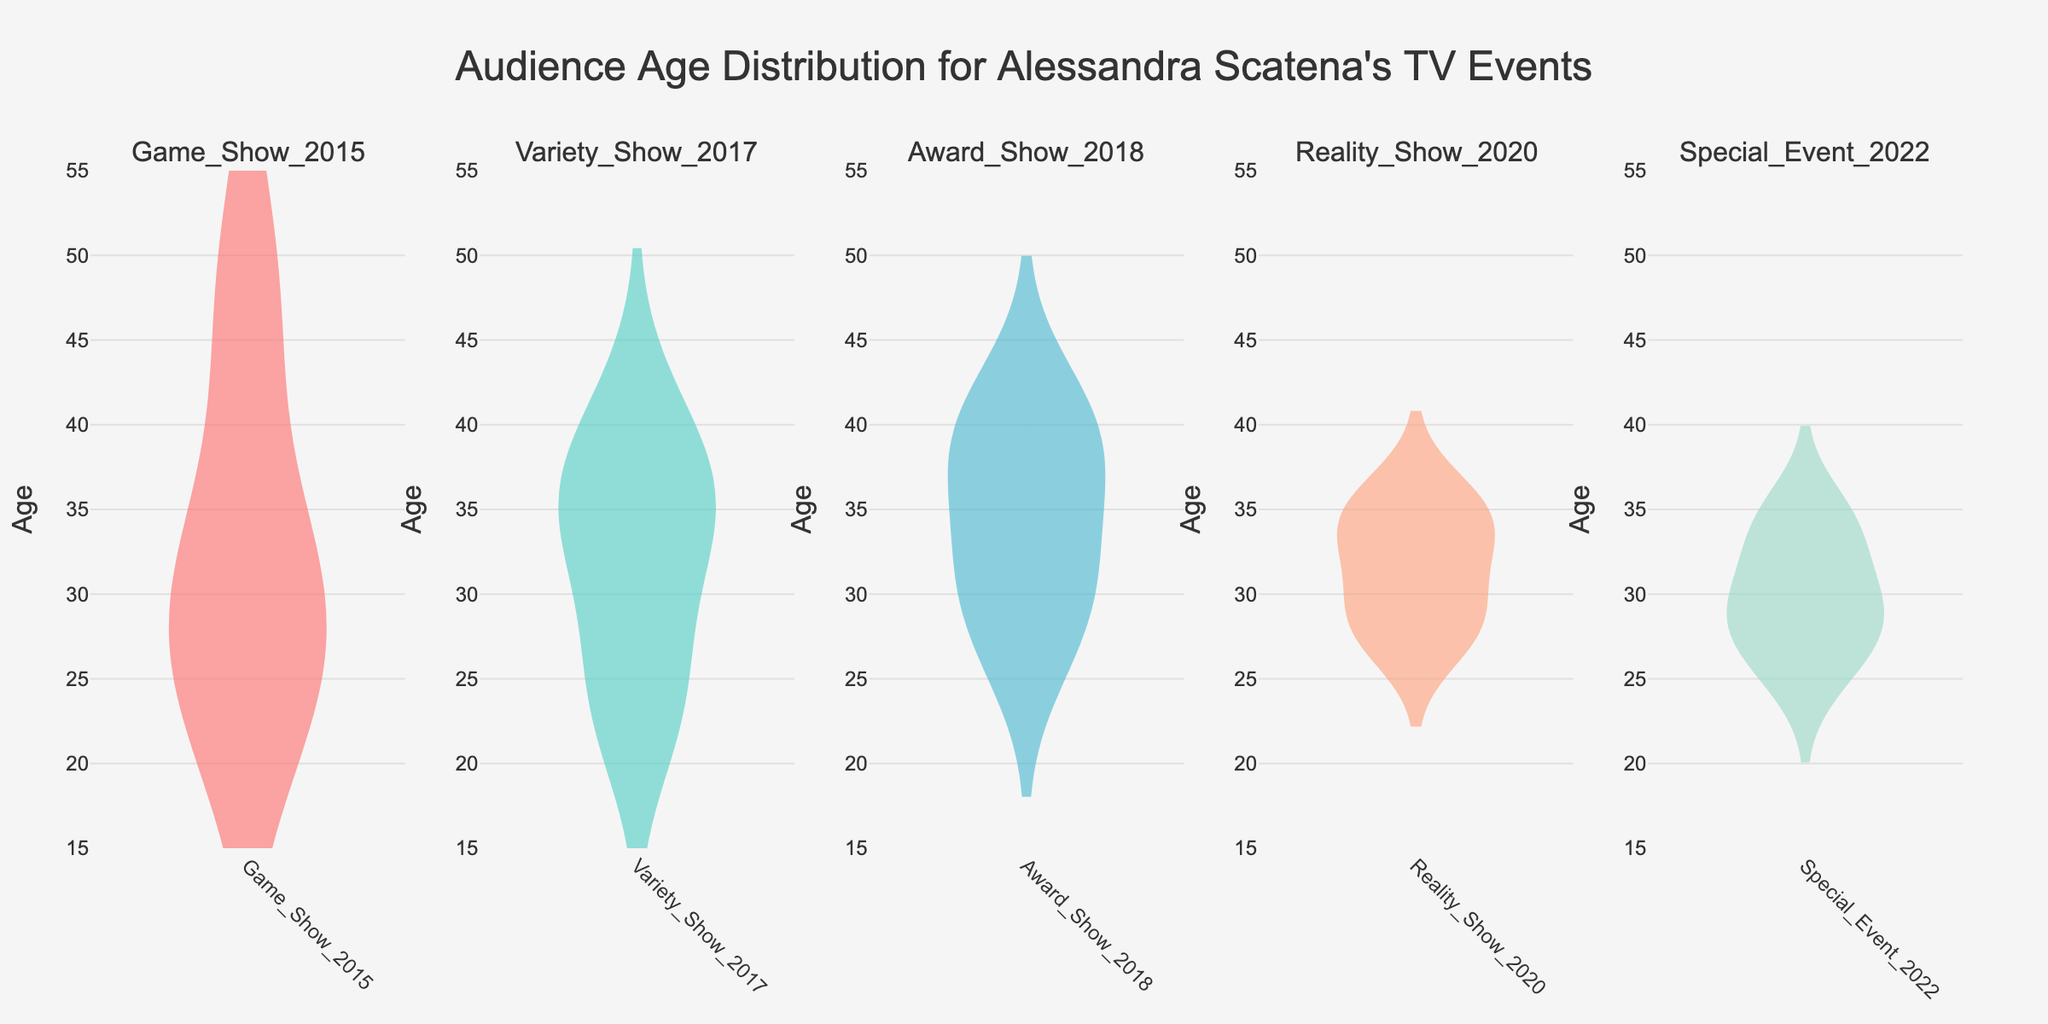What is the title of the figure? The title is found at the top of the figure. It provides an overview of what the figure represents.
Answer: Audience Age Distribution for Alessandra Scatena's TV Events How many subplots are there in the figure? The figure is divided into multiple vertical sections, each representing a different televised event. Count the number of these sections to determine the number of subplots.
Answer: 5 What is the age range covered on the y-axis? Look at the numerical values on the y-axis to determine the minimum and maximum values represented.
Answer: 15 to 55 Which event shows the widest age distribution? Compare the spread of the data points (indicated by the width of the violin plots) across the different events to determine which one is the widest.
Answer: Game_Show_2015 Which event has the highest median age? Locate the central mark on each violin plot that denotes the median age and determine which subplot has the highest median.
Answer: Award_Show_2018 How does the median age of the 'Reality_Show_2020' compare to the 'Special_Event_2022'? Identify the median indicators on the violin plots for these two events and compare their values to see which one is higher.
Answer: The median age of 'Reality_Show_2020' is slightly higher than 'Special_Event_2022' Which subplot shows the smallest interquartile range (IQR)? The interquartile range is the range between the first quartile (25th percentile) and third quartile (75th percentile). Look at the widths of the boxes within each violin plot to identify the subplot with the smallest IQR.
Answer: Variety_Show_2017 What is the approximate median age for 'Special_Event_2022'? Locate the median line within the 'Special_Event_2022' subplot and approximate the corresponding y-axis value.
Answer: Approximately 29 Is there any event where the age distribution appears almost symmetric? Look at the shape of the violin plots and determine which one has a distribution that is roughly the same on both sides of the centerline.
Answer: Reality_Show_2020 How many different colors are used for the violin plots? Count the distinct colors used to fill the violin plots across all subplots.
Answer: 5 